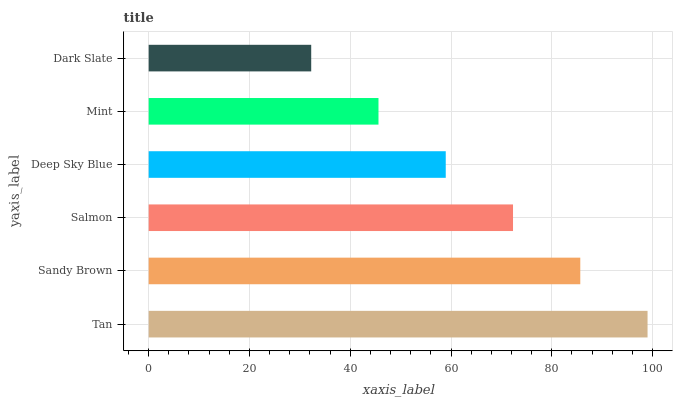Is Dark Slate the minimum?
Answer yes or no. Yes. Is Tan the maximum?
Answer yes or no. Yes. Is Sandy Brown the minimum?
Answer yes or no. No. Is Sandy Brown the maximum?
Answer yes or no. No. Is Tan greater than Sandy Brown?
Answer yes or no. Yes. Is Sandy Brown less than Tan?
Answer yes or no. Yes. Is Sandy Brown greater than Tan?
Answer yes or no. No. Is Tan less than Sandy Brown?
Answer yes or no. No. Is Salmon the high median?
Answer yes or no. Yes. Is Deep Sky Blue the low median?
Answer yes or no. Yes. Is Deep Sky Blue the high median?
Answer yes or no. No. Is Mint the low median?
Answer yes or no. No. 